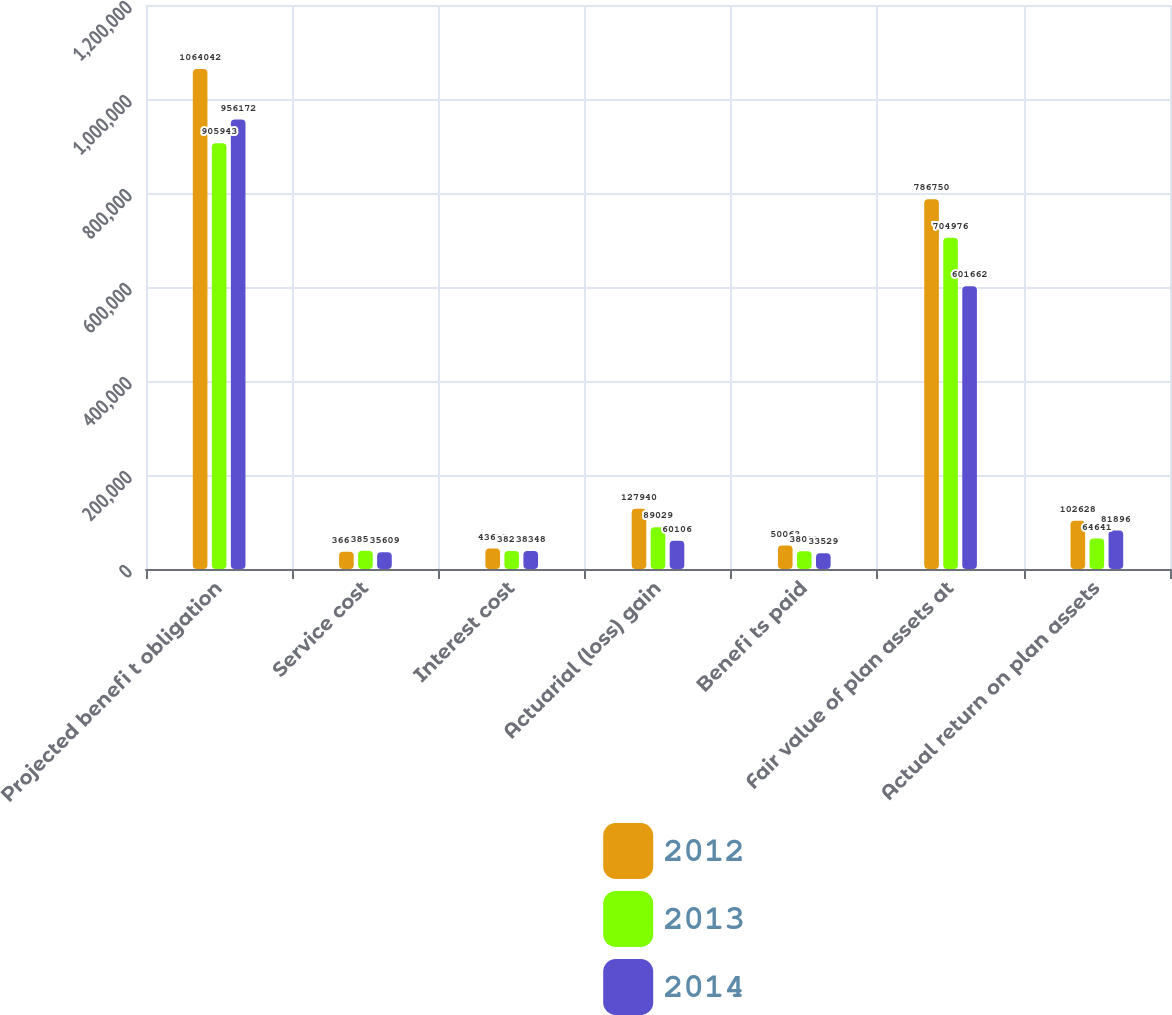Convert chart. <chart><loc_0><loc_0><loc_500><loc_500><stacked_bar_chart><ecel><fcel>Projected benefi t obligation<fcel>Service cost<fcel>Interest cost<fcel>Actuarial (loss) gain<fcel>Benefi ts paid<fcel>Fair value of plan assets at<fcel>Actual return on plan assets<nl><fcel>2012<fcel>1.06404e+06<fcel>36609<fcel>43613<fcel>127940<fcel>50063<fcel>786750<fcel>102628<nl><fcel>2013<fcel>905943<fcel>38580<fcel>38243<fcel>89029<fcel>38023<fcel>704976<fcel>64641<nl><fcel>2014<fcel>956172<fcel>35609<fcel>38348<fcel>60106<fcel>33529<fcel>601662<fcel>81896<nl></chart> 